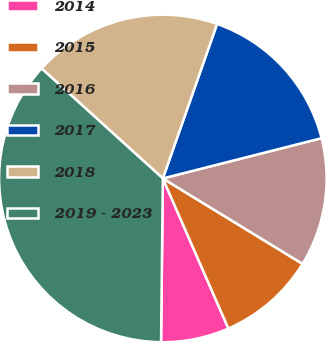Convert chart. <chart><loc_0><loc_0><loc_500><loc_500><pie_chart><fcel>2014<fcel>2015<fcel>2016<fcel>2017<fcel>2018<fcel>2019 - 2023<nl><fcel>6.73%<fcel>9.71%<fcel>12.69%<fcel>15.67%<fcel>18.65%<fcel>36.55%<nl></chart> 